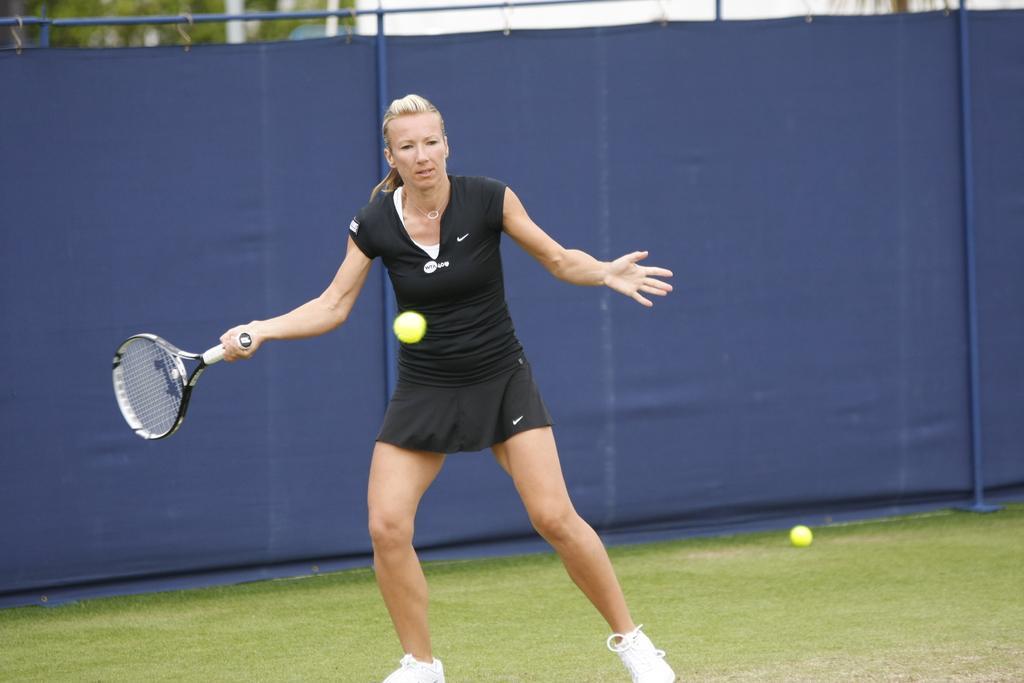In one or two sentences, can you explain what this image depicts? In this image I can see a woman standing and holding a bat in her hand. In the background there is a blue color cloth. It seems like a playing ground. 